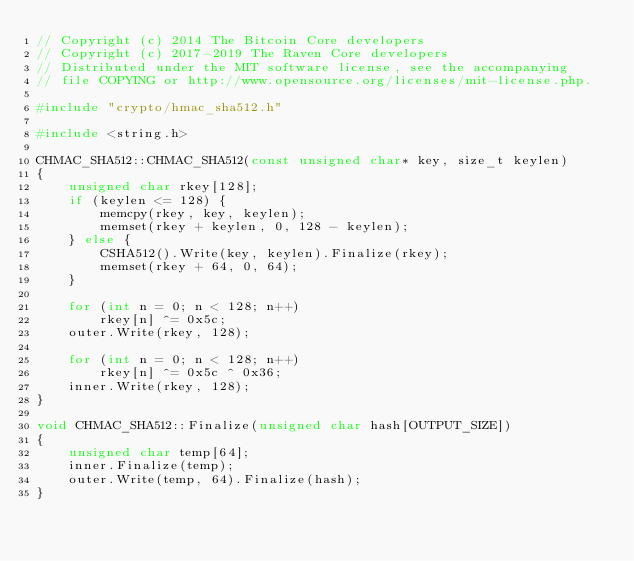Convert code to text. <code><loc_0><loc_0><loc_500><loc_500><_C++_>// Copyright (c) 2014 The Bitcoin Core developers
// Copyright (c) 2017-2019 The Raven Core developers
// Distributed under the MIT software license, see the accompanying
// file COPYING or http://www.opensource.org/licenses/mit-license.php.

#include "crypto/hmac_sha512.h"

#include <string.h>

CHMAC_SHA512::CHMAC_SHA512(const unsigned char* key, size_t keylen)
{
    unsigned char rkey[128];
    if (keylen <= 128) {
        memcpy(rkey, key, keylen);
        memset(rkey + keylen, 0, 128 - keylen);
    } else {
        CSHA512().Write(key, keylen).Finalize(rkey);
        memset(rkey + 64, 0, 64);
    }

    for (int n = 0; n < 128; n++)
        rkey[n] ^= 0x5c;
    outer.Write(rkey, 128);

    for (int n = 0; n < 128; n++)
        rkey[n] ^= 0x5c ^ 0x36;
    inner.Write(rkey, 128);
}

void CHMAC_SHA512::Finalize(unsigned char hash[OUTPUT_SIZE])
{
    unsigned char temp[64];
    inner.Finalize(temp);
    outer.Write(temp, 64).Finalize(hash);
}
</code> 